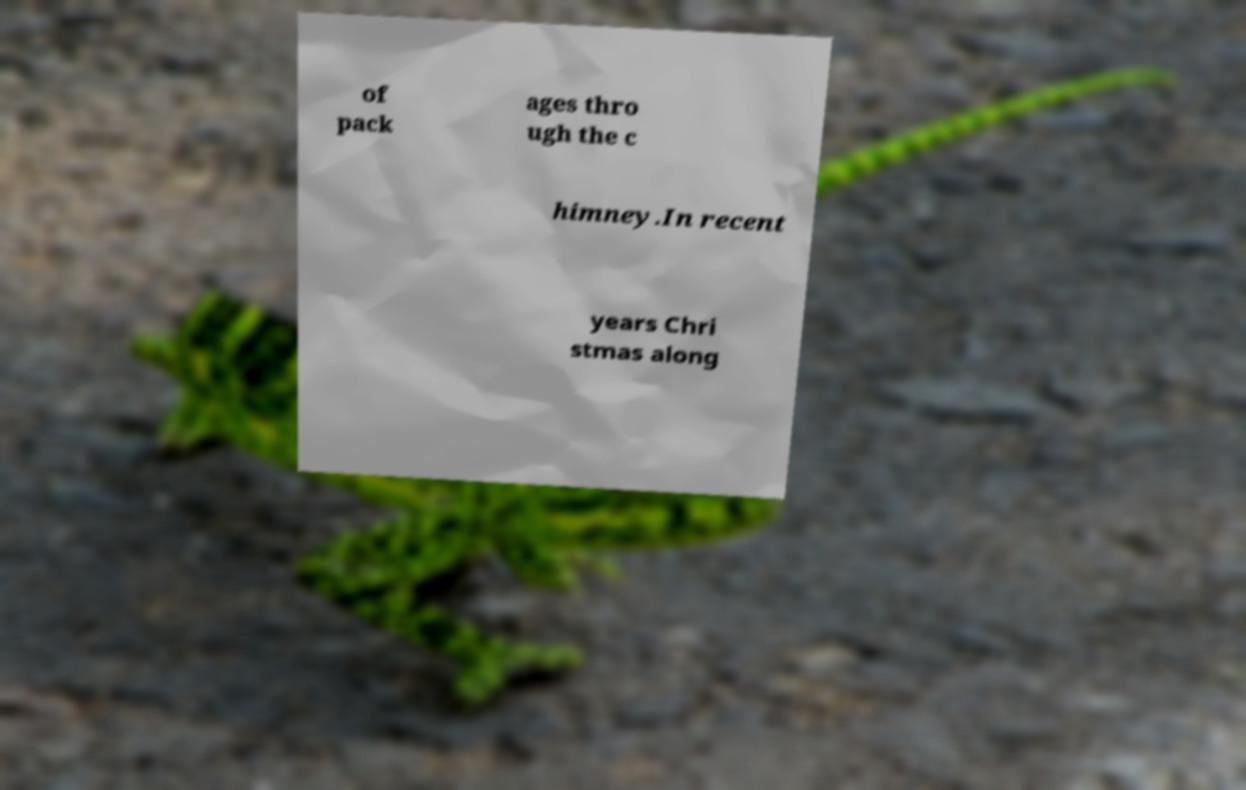Please identify and transcribe the text found in this image. of pack ages thro ugh the c himney.In recent years Chri stmas along 